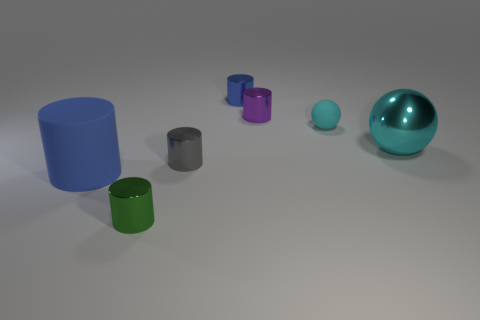Subtract all small blue metallic cylinders. How many cylinders are left? 4 Add 3 blue metallic cylinders. How many objects exist? 10 Subtract all green cylinders. How many cylinders are left? 4 Subtract all spheres. How many objects are left? 5 Subtract 1 balls. How many balls are left? 1 Subtract all green spheres. How many red cylinders are left? 0 Subtract all large metallic spheres. Subtract all big rubber things. How many objects are left? 5 Add 3 green cylinders. How many green cylinders are left? 4 Add 2 small gray matte objects. How many small gray matte objects exist? 2 Subtract 0 cyan cylinders. How many objects are left? 7 